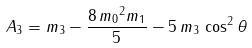Convert formula to latex. <formula><loc_0><loc_0><loc_500><loc_500>A _ { 3 } = { m _ { 3 } } - { \frac { 8 \, { m _ { 0 } } ^ { 2 } { m _ { 1 } } } { 5 } } - 5 \, { m _ { 3 } } \, \cos ^ { 2 } \theta</formula> 